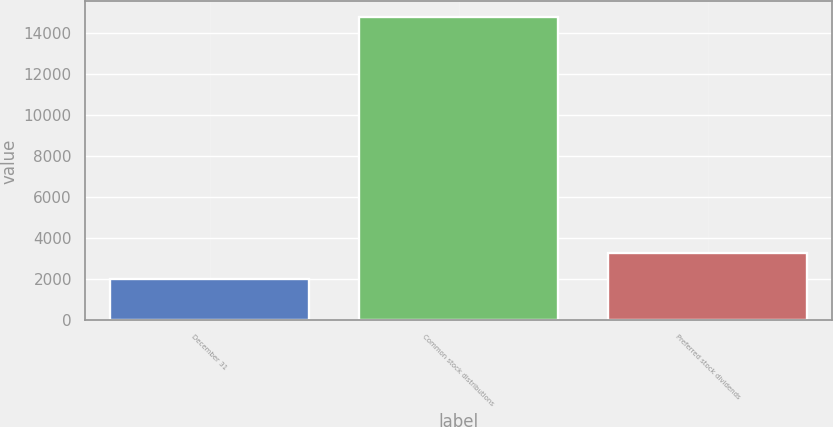Convert chart. <chart><loc_0><loc_0><loc_500><loc_500><bar_chart><fcel>December 31<fcel>Common stock distributions<fcel>Preferred stock dividends<nl><fcel>2008<fcel>14772<fcel>3284.4<nl></chart> 